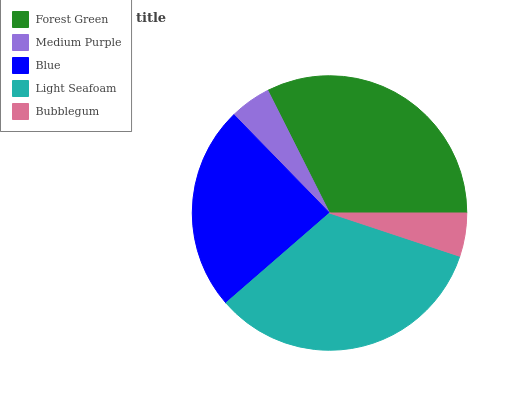Is Medium Purple the minimum?
Answer yes or no. Yes. Is Light Seafoam the maximum?
Answer yes or no. Yes. Is Blue the minimum?
Answer yes or no. No. Is Blue the maximum?
Answer yes or no. No. Is Blue greater than Medium Purple?
Answer yes or no. Yes. Is Medium Purple less than Blue?
Answer yes or no. Yes. Is Medium Purple greater than Blue?
Answer yes or no. No. Is Blue less than Medium Purple?
Answer yes or no. No. Is Blue the high median?
Answer yes or no. Yes. Is Blue the low median?
Answer yes or no. Yes. Is Light Seafoam the high median?
Answer yes or no. No. Is Medium Purple the low median?
Answer yes or no. No. 